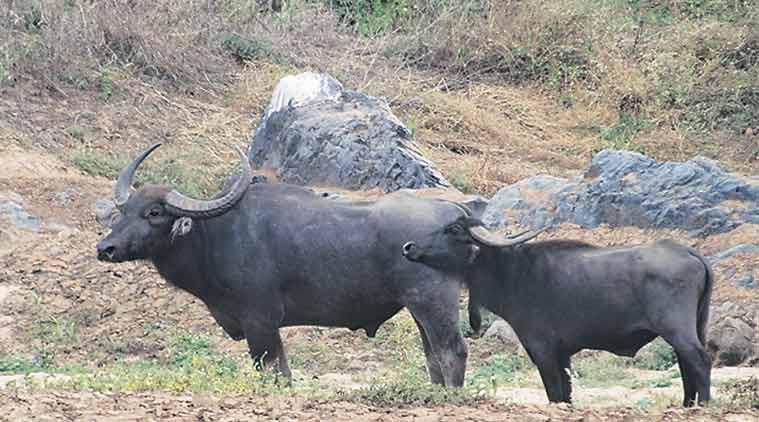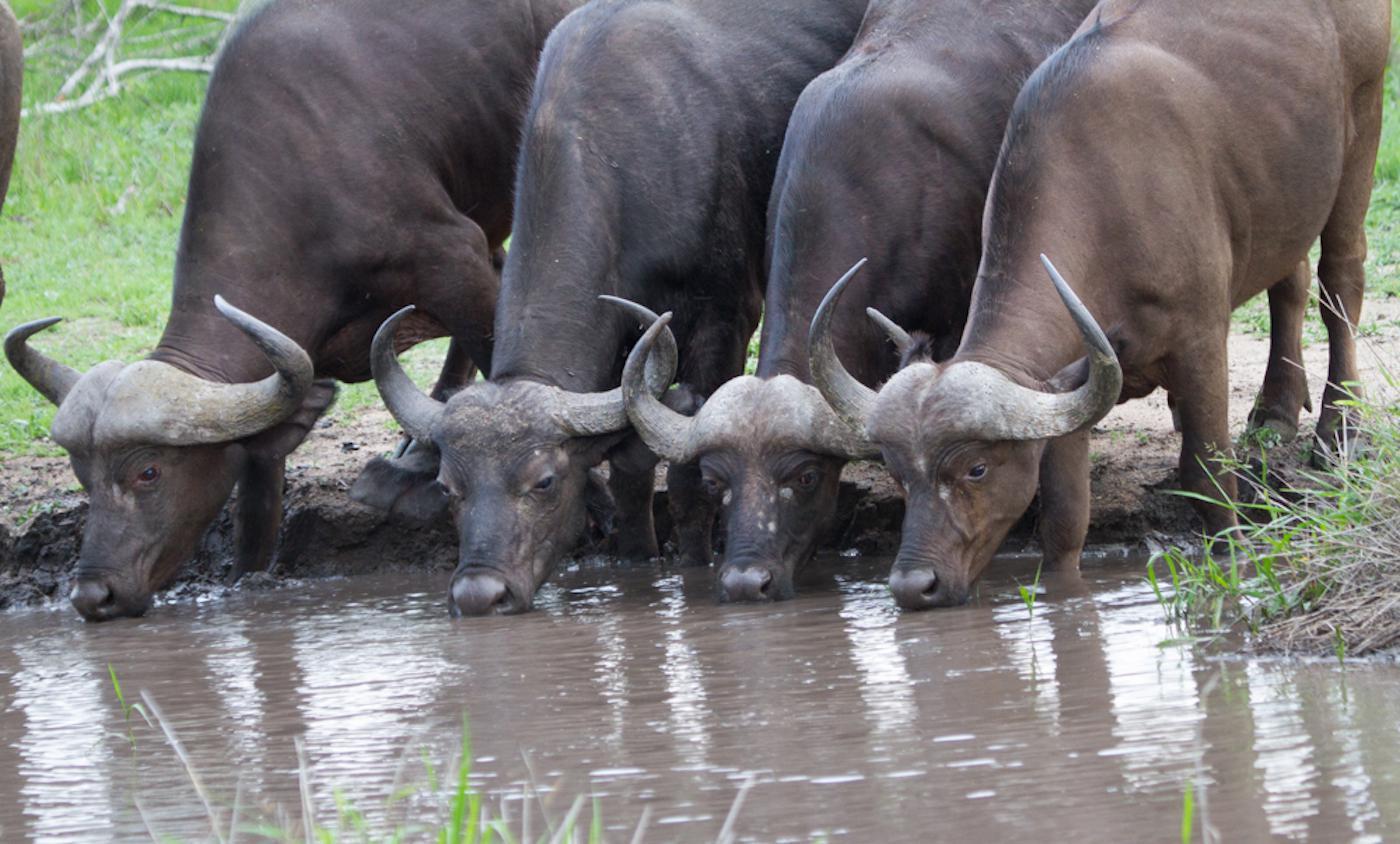The first image is the image on the left, the second image is the image on the right. For the images shown, is this caption "water buffalo are at the water hole" true? Answer yes or no. Yes. The first image is the image on the left, the second image is the image on the right. Considering the images on both sides, is "There are no more than six water buffaloes in the left image." valid? Answer yes or no. Yes. 